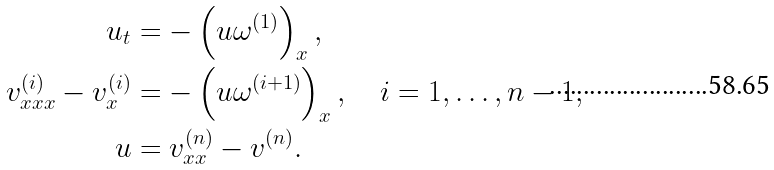Convert formula to latex. <formula><loc_0><loc_0><loc_500><loc_500>u _ { t } & = - \left ( u \omega ^ { ( 1 ) } \right ) _ { x } , \\ v ^ { ( i ) } _ { x x x } - v ^ { ( i ) } _ { x } & = - \left ( u \omega ^ { ( i + 1 ) } \right ) _ { x } , \quad i = 1 , \dots , n - 1 , \\ u & = v ^ { ( n ) } _ { x x } - v ^ { ( n ) } .</formula> 